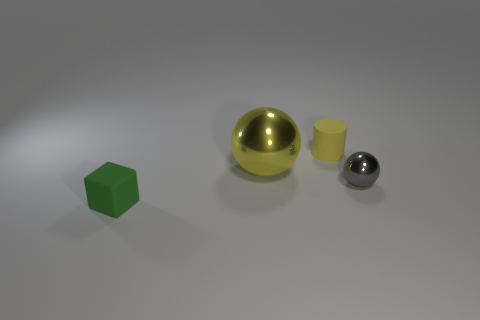The object that is the same color as the tiny rubber cylinder is what shape?
Make the answer very short. Sphere. How many objects have the same material as the tiny gray sphere?
Your answer should be very brief. 1. There is a small green matte object; what number of rubber things are left of it?
Your answer should be very brief. 0. The gray shiny thing is what size?
Ensure brevity in your answer.  Small. There is a matte cylinder that is the same size as the gray metallic ball; what is its color?
Make the answer very short. Yellow. Is there another tiny rubber cylinder of the same color as the matte cylinder?
Offer a very short reply. No. What is the small yellow thing made of?
Your answer should be very brief. Rubber. How many tiny gray metallic things are there?
Your answer should be compact. 1. Do the matte thing to the right of the green block and the metal ball left of the small yellow rubber cylinder have the same color?
Keep it short and to the point. Yes. What is the size of the other thing that is the same color as the large metallic object?
Provide a short and direct response. Small. 